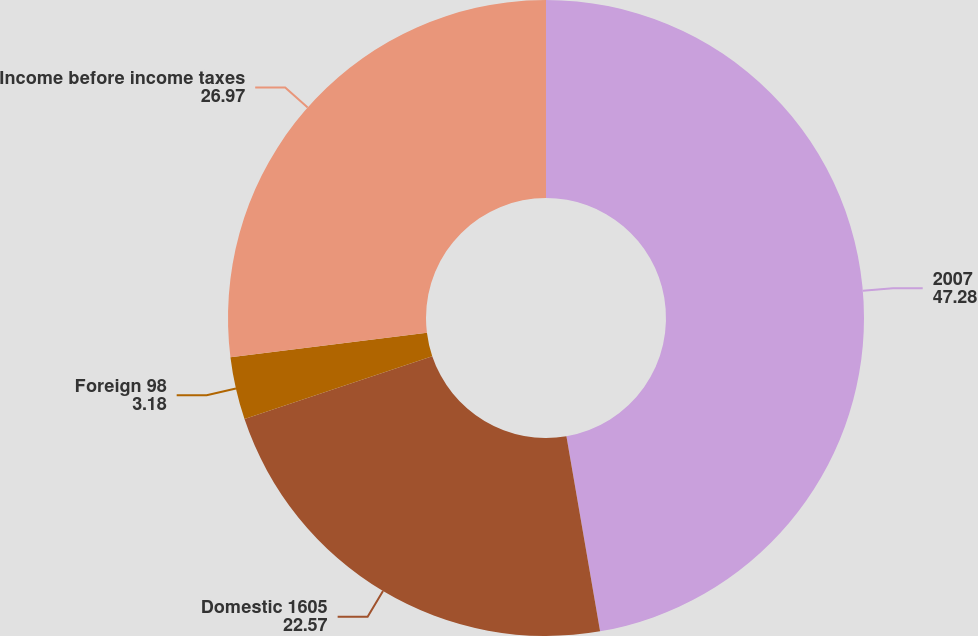Convert chart to OTSL. <chart><loc_0><loc_0><loc_500><loc_500><pie_chart><fcel>2007<fcel>Domestic 1605<fcel>Foreign 98<fcel>Income before income taxes<nl><fcel>47.28%<fcel>22.57%<fcel>3.18%<fcel>26.97%<nl></chart> 